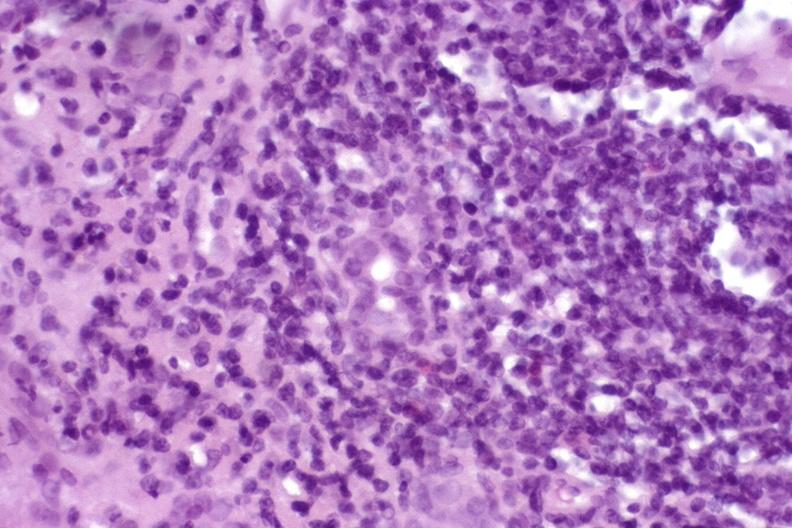s liver present?
Answer the question using a single word or phrase. Yes 